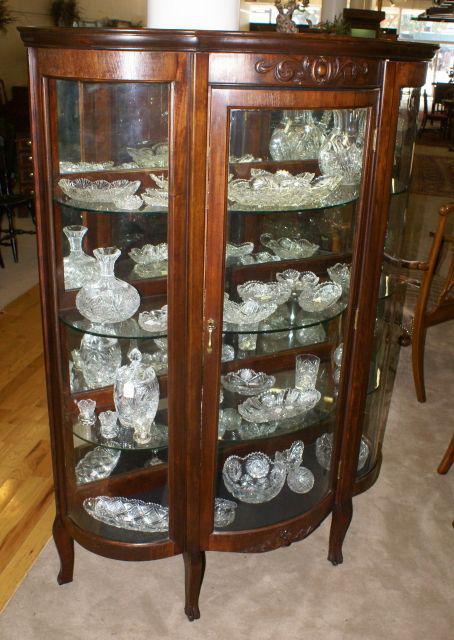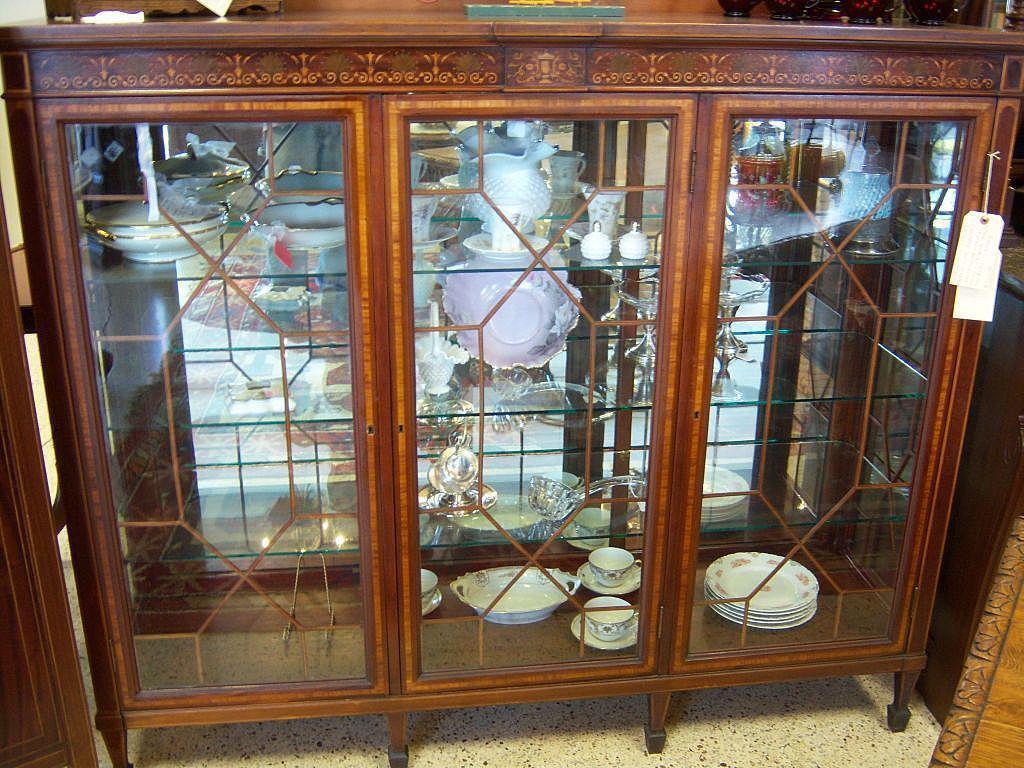The first image is the image on the left, the second image is the image on the right. For the images shown, is this caption "A wood china cupboard in one image has a curved glass front and glass shelves, carving above the door and small feet." true? Answer yes or no. Yes. 